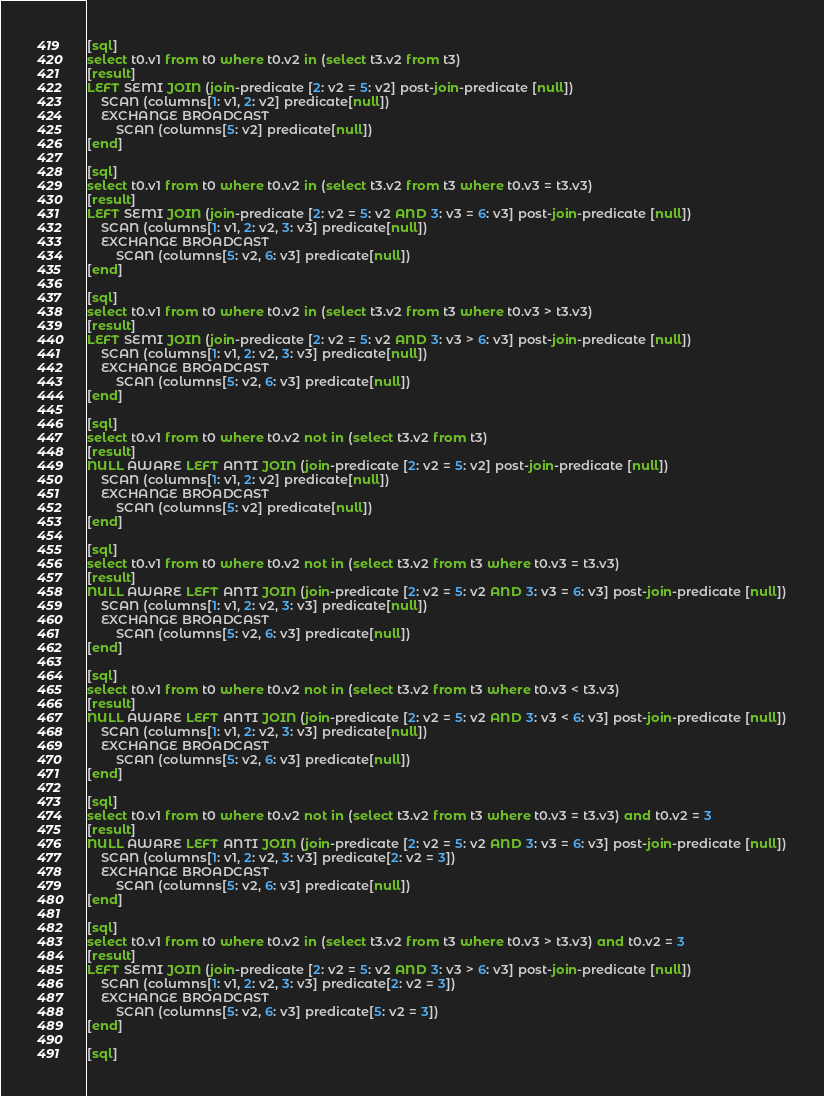Convert code to text. <code><loc_0><loc_0><loc_500><loc_500><_SQL_>[sql]
select t0.v1 from t0 where t0.v2 in (select t3.v2 from t3)
[result]
LEFT SEMI JOIN (join-predicate [2: v2 = 5: v2] post-join-predicate [null])
    SCAN (columns[1: v1, 2: v2] predicate[null])
    EXCHANGE BROADCAST
        SCAN (columns[5: v2] predicate[null])
[end]

[sql]
select t0.v1 from t0 where t0.v2 in (select t3.v2 from t3 where t0.v3 = t3.v3)
[result]
LEFT SEMI JOIN (join-predicate [2: v2 = 5: v2 AND 3: v3 = 6: v3] post-join-predicate [null])
    SCAN (columns[1: v1, 2: v2, 3: v3] predicate[null])
    EXCHANGE BROADCAST
        SCAN (columns[5: v2, 6: v3] predicate[null])
[end]

[sql]
select t0.v1 from t0 where t0.v2 in (select t3.v2 from t3 where t0.v3 > t3.v3)
[result]
LEFT SEMI JOIN (join-predicate [2: v2 = 5: v2 AND 3: v3 > 6: v3] post-join-predicate [null])
    SCAN (columns[1: v1, 2: v2, 3: v3] predicate[null])
    EXCHANGE BROADCAST
        SCAN (columns[5: v2, 6: v3] predicate[null])
[end]

[sql]
select t0.v1 from t0 where t0.v2 not in (select t3.v2 from t3)
[result]
NULL AWARE LEFT ANTI JOIN (join-predicate [2: v2 = 5: v2] post-join-predicate [null])
    SCAN (columns[1: v1, 2: v2] predicate[null])
    EXCHANGE BROADCAST
        SCAN (columns[5: v2] predicate[null])
[end]

[sql]
select t0.v1 from t0 where t0.v2 not in (select t3.v2 from t3 where t0.v3 = t3.v3)
[result]
NULL AWARE LEFT ANTI JOIN (join-predicate [2: v2 = 5: v2 AND 3: v3 = 6: v3] post-join-predicate [null])
    SCAN (columns[1: v1, 2: v2, 3: v3] predicate[null])
    EXCHANGE BROADCAST
        SCAN (columns[5: v2, 6: v3] predicate[null])
[end]

[sql]
select t0.v1 from t0 where t0.v2 not in (select t3.v2 from t3 where t0.v3 < t3.v3)
[result]
NULL AWARE LEFT ANTI JOIN (join-predicate [2: v2 = 5: v2 AND 3: v3 < 6: v3] post-join-predicate [null])
    SCAN (columns[1: v1, 2: v2, 3: v3] predicate[null])
    EXCHANGE BROADCAST
        SCAN (columns[5: v2, 6: v3] predicate[null])
[end]

[sql]
select t0.v1 from t0 where t0.v2 not in (select t3.v2 from t3 where t0.v3 = t3.v3) and t0.v2 = 3
[result]
NULL AWARE LEFT ANTI JOIN (join-predicate [2: v2 = 5: v2 AND 3: v3 = 6: v3] post-join-predicate [null])
    SCAN (columns[1: v1, 2: v2, 3: v3] predicate[2: v2 = 3])
    EXCHANGE BROADCAST
        SCAN (columns[5: v2, 6: v3] predicate[null])
[end]

[sql]
select t0.v1 from t0 where t0.v2 in (select t3.v2 from t3 where t0.v3 > t3.v3) and t0.v2 = 3
[result]
LEFT SEMI JOIN (join-predicate [2: v2 = 5: v2 AND 3: v3 > 6: v3] post-join-predicate [null])
    SCAN (columns[1: v1, 2: v2, 3: v3] predicate[2: v2 = 3])
    EXCHANGE BROADCAST
        SCAN (columns[5: v2, 6: v3] predicate[5: v2 = 3])
[end]

[sql]</code> 